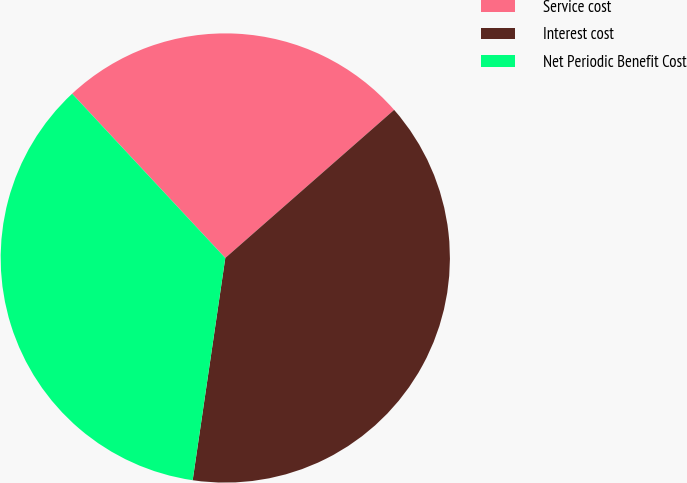Convert chart. <chart><loc_0><loc_0><loc_500><loc_500><pie_chart><fcel>Service cost<fcel>Interest cost<fcel>Net Periodic Benefit Cost<nl><fcel>25.48%<fcel>38.78%<fcel>35.74%<nl></chart> 